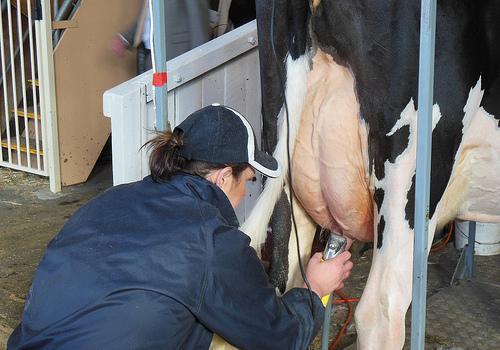How many cows are there?
Give a very brief answer. 1. How many people are in the picture?
Give a very brief answer. 2. 